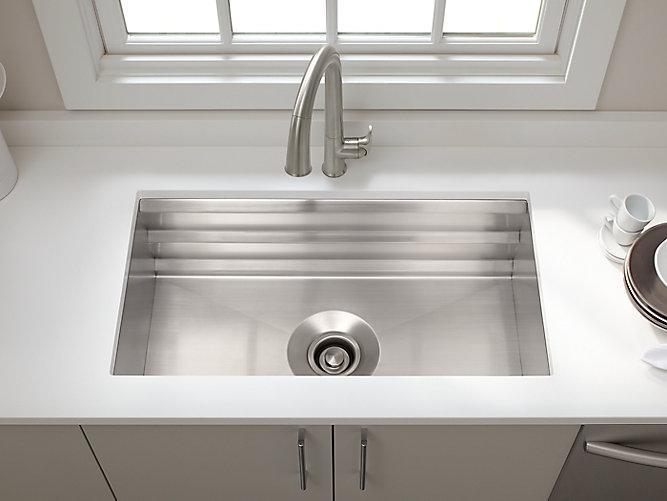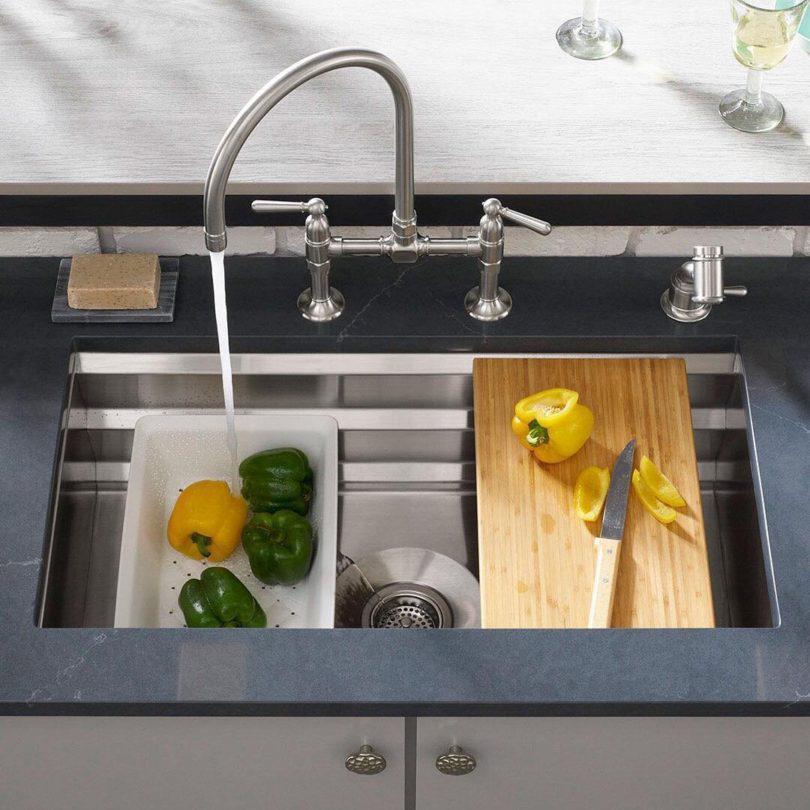The first image is the image on the left, the second image is the image on the right. Examine the images to the left and right. Is the description "A bottle is being filled with water from a faucet in the left image." accurate? Answer yes or no. No. The first image is the image on the left, the second image is the image on the right. Evaluate the accuracy of this statement regarding the images: "A lemon sits on a white rack near the sink in one of the images.". Is it true? Answer yes or no. No. 